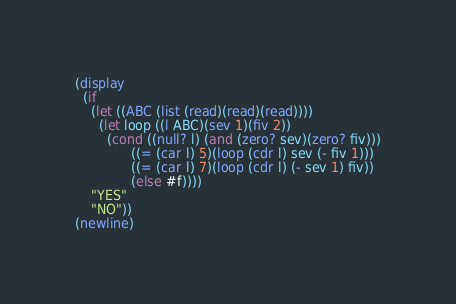<code> <loc_0><loc_0><loc_500><loc_500><_Scheme_>(display
  (if 
    (let ((ABC (list (read)(read)(read))))
      (let loop ((l ABC)(sev 1)(fiv 2))
        (cond ((null? l) (and (zero? sev)(zero? fiv)))
              ((= (car l) 5)(loop (cdr l) sev (- fiv 1)))
              ((= (car l) 7)(loop (cdr l) (- sev 1) fiv))
              (else #f))))
    "YES"
    "NO"))
(newline)
</code> 